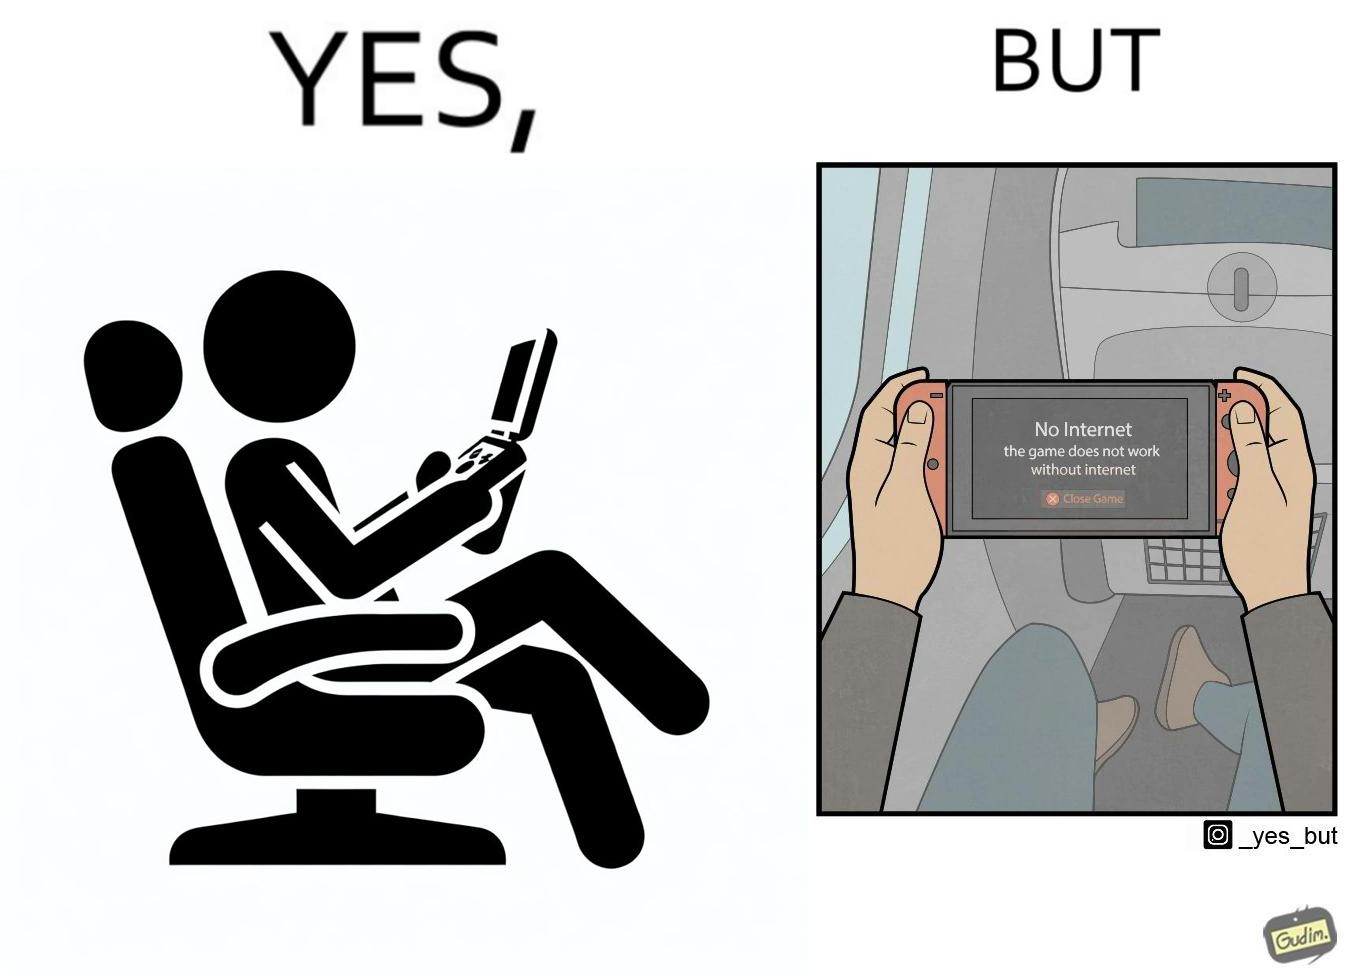Describe the satirical element in this image. The image is ironic, as the person is holding the game console to play a game during the flight. However, the person is unable to play the game, as the game requires internet (as is the case with many modern games), and internet is unavailable in many lights. 